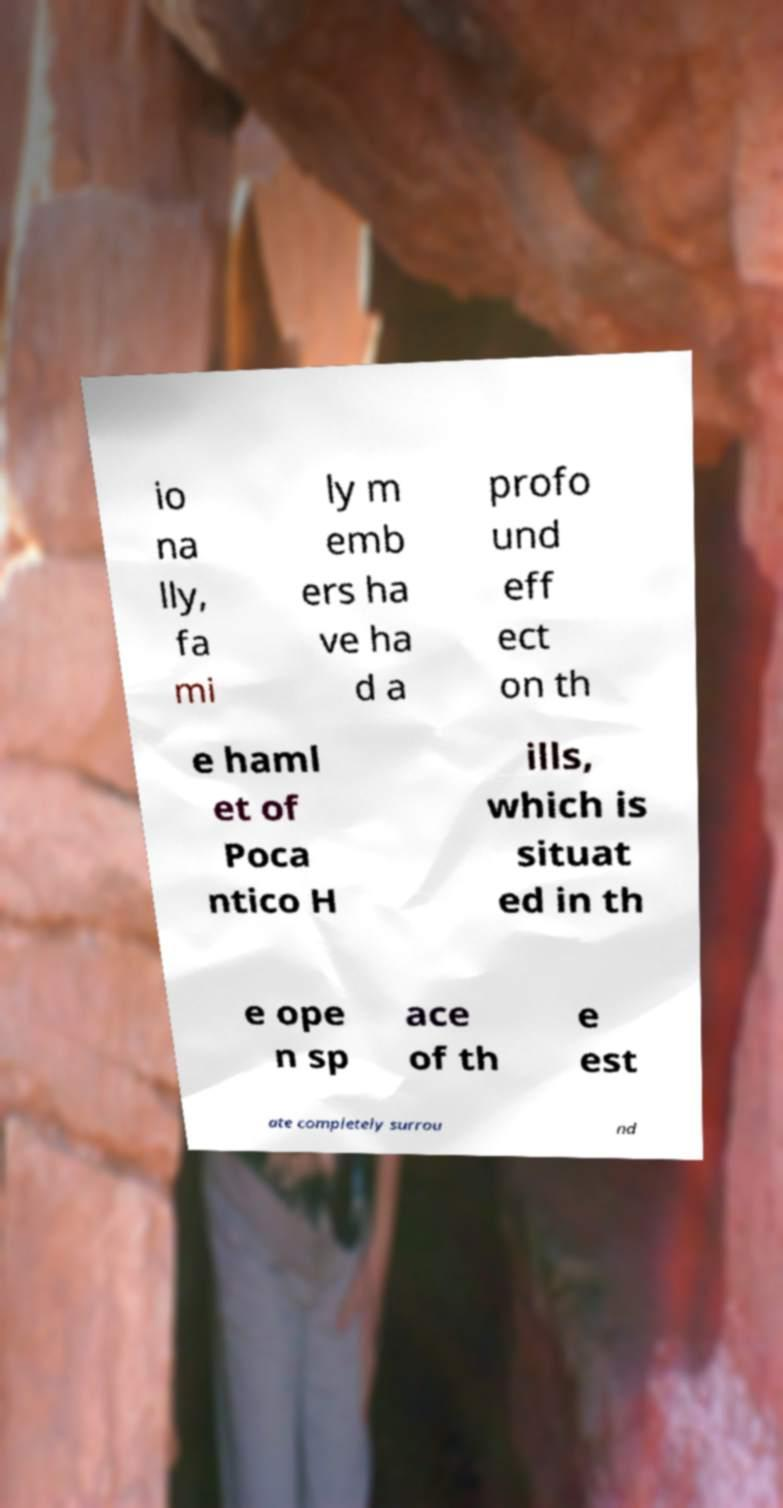Could you extract and type out the text from this image? io na lly, fa mi ly m emb ers ha ve ha d a profo und eff ect on th e haml et of Poca ntico H ills, which is situat ed in th e ope n sp ace of th e est ate completely surrou nd 